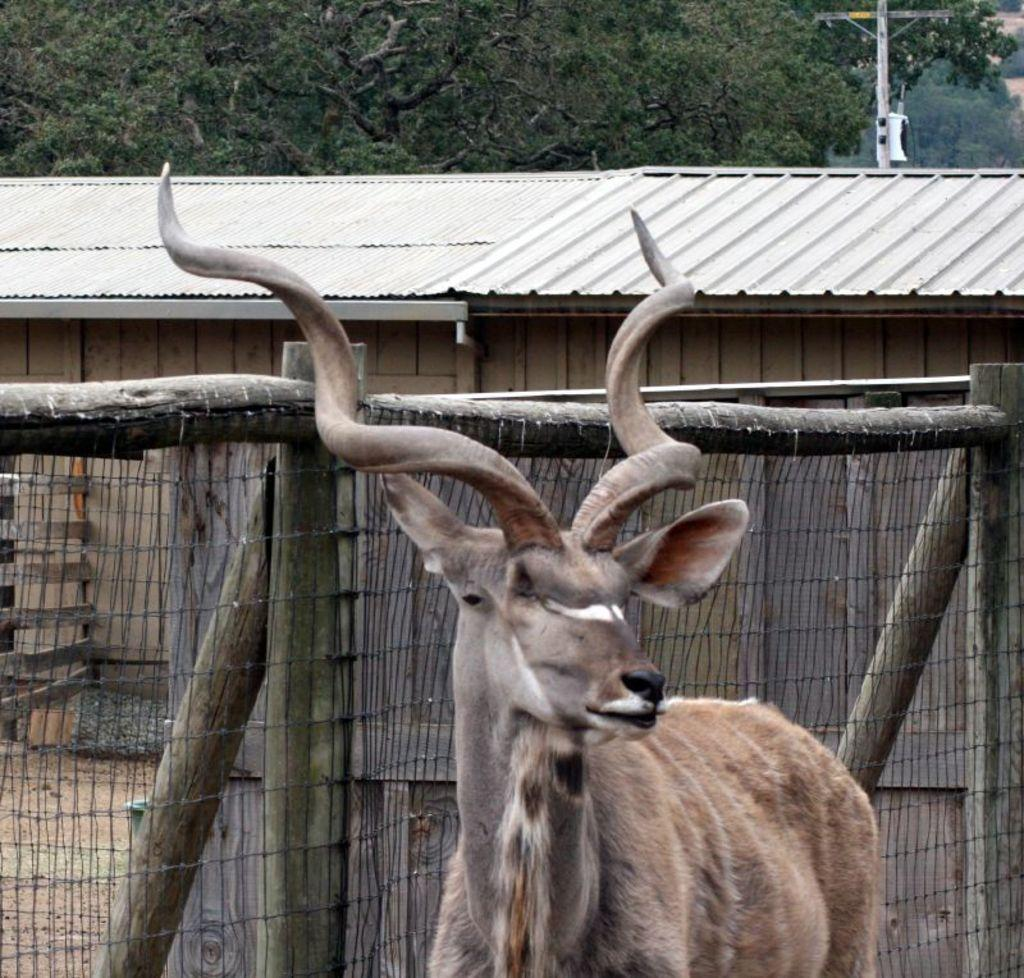What type of animal is in the image? The type of animal cannot be determined from the provided facts. What is located behind the animal in the image? There is fencing and a house behind the animal in the image. What is at the top of the image? There is a pole and a group of trees visible at the top of the image. What type of engine can be seen powering the ant in the image? There is no ant or engine present in the image. 